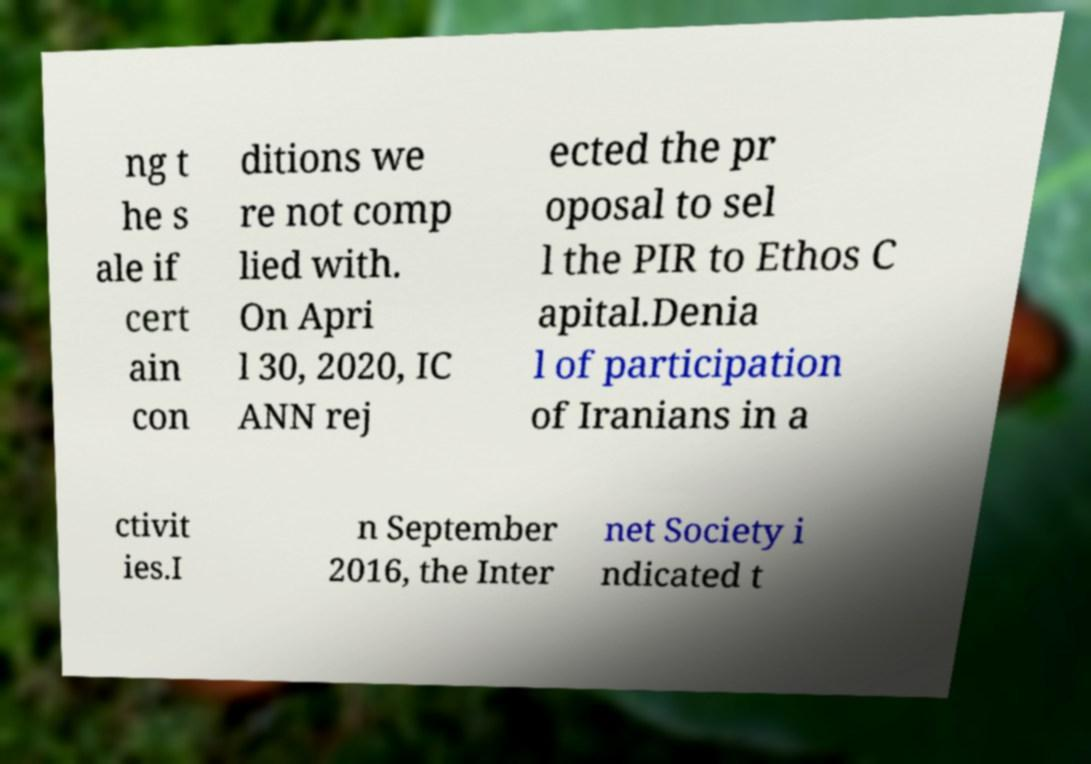Could you assist in decoding the text presented in this image and type it out clearly? ng t he s ale if cert ain con ditions we re not comp lied with. On Apri l 30, 2020, IC ANN rej ected the pr oposal to sel l the PIR to Ethos C apital.Denia l of participation of Iranians in a ctivit ies.I n September 2016, the Inter net Society i ndicated t 